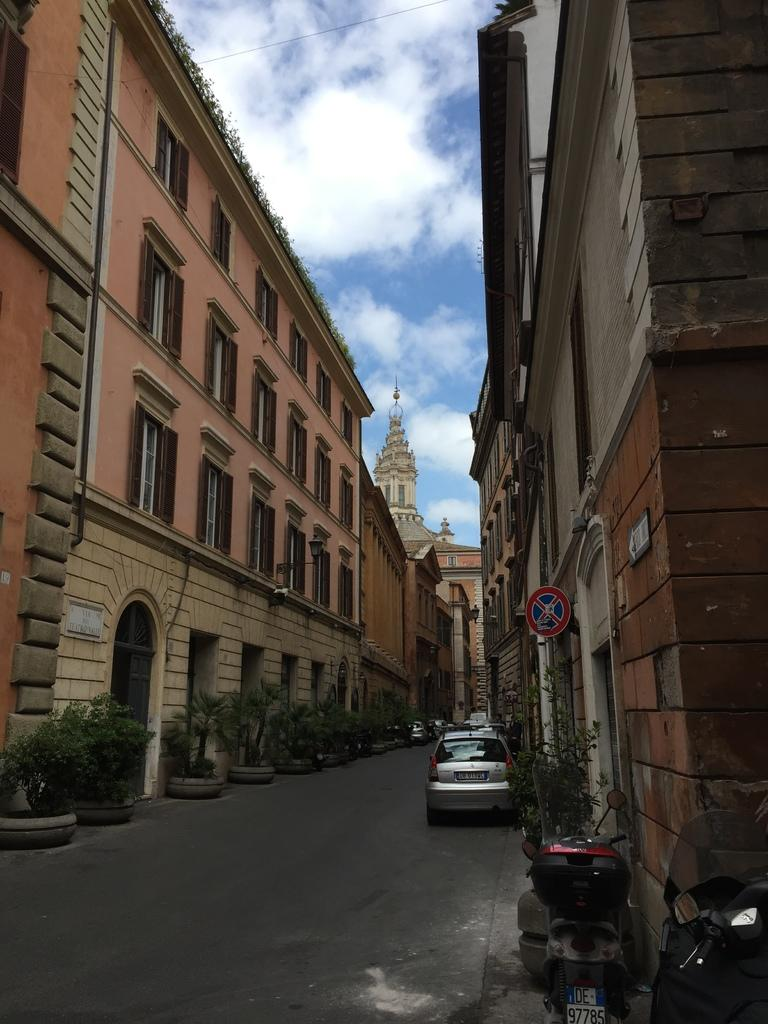What type of structures can be seen in the image? There are buildings in the image. What else is present in the image besides buildings? There are plants and vehicles on the road in the image. How would you describe the sky in the image? The sky is cloudy in the image. Are there any grain fields visible in the image? There is no mention of grain fields in the provided facts, so it cannot be determined if they are present in the image. 